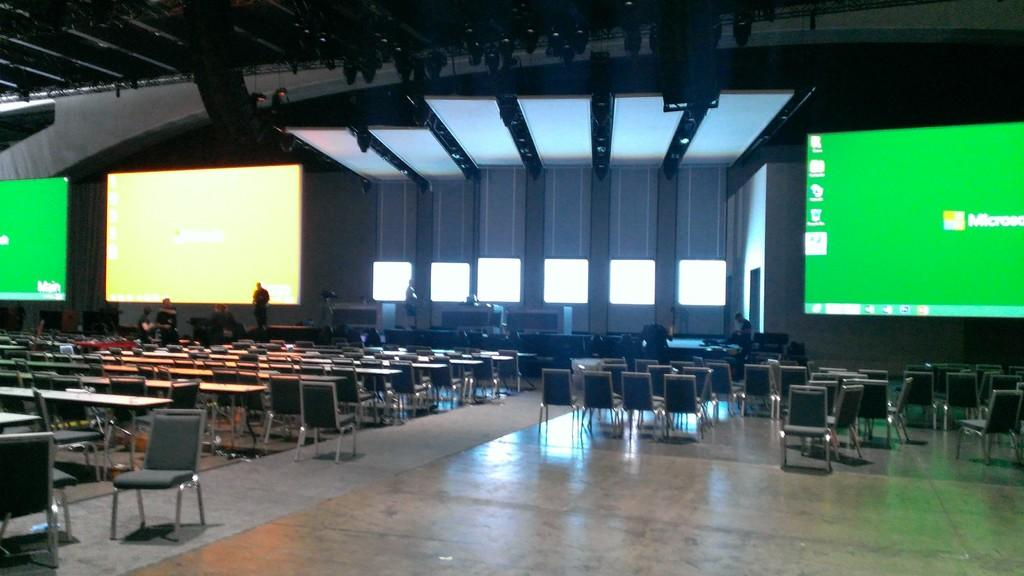What is located at the top of the image? There are screens on the top of the image. What can be seen on the stage in the image? There are people standing on a stage in the image. How is the hall depicted in the image furnished? There are many chairs in the hall depicted in the image. How many parcels are being delivered on the stage in the image? There are no parcels visible in the image; it features people standing on a stage. What is the rate of the people sleeping on the stage in the image? There are no people sleeping in the image; the people on the stage are standing. 